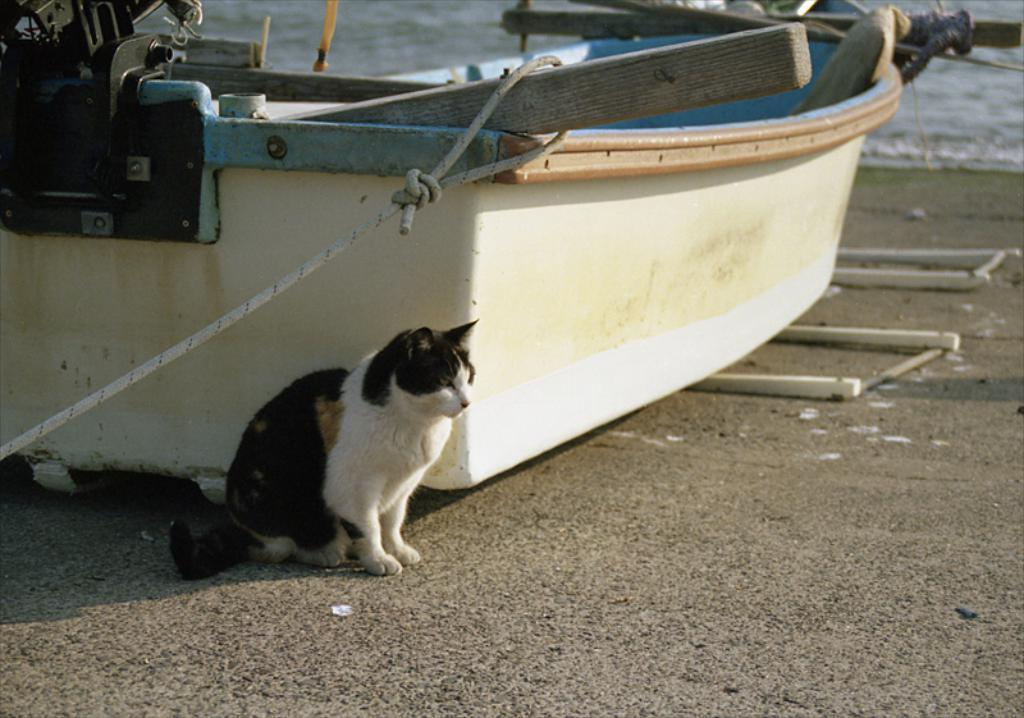What animal is present in the image? There is a cat in the image. Where is the cat located in relation to the boat? The cat is sitting beside a boat. What type of environment is the boat located in? The boat is on the seashore. What can be seen in the background of the image? There is a sea visible in the background of the image. What type of attraction can be seen in the image? There is no attraction present in the image; it features a cat sitting beside a boat on the seashore. What type of humor is depicted in the image? There is no humor depicted in the image; it is a simple scene of a cat and a boat. 